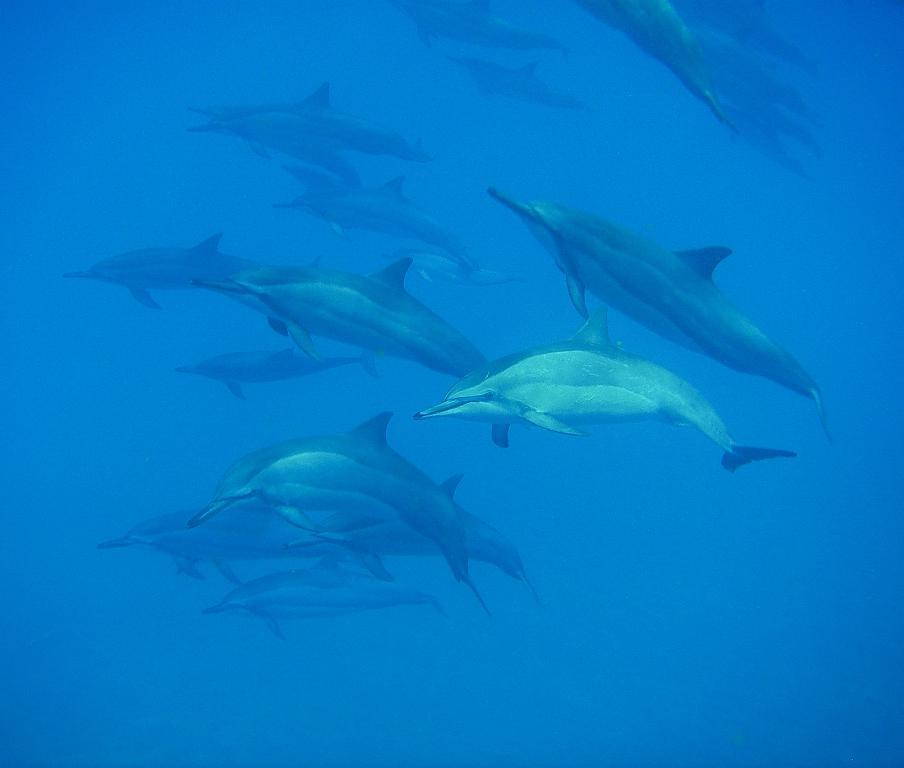What type of animals can be seen in the image? There are fishes in the image. Where are the fishes located? The fishes are in the water. What is the reason for the fishes going on vacation in the image? There is no indication in the image that the fishes are going on vacation, nor is there any context provided for such an event. 